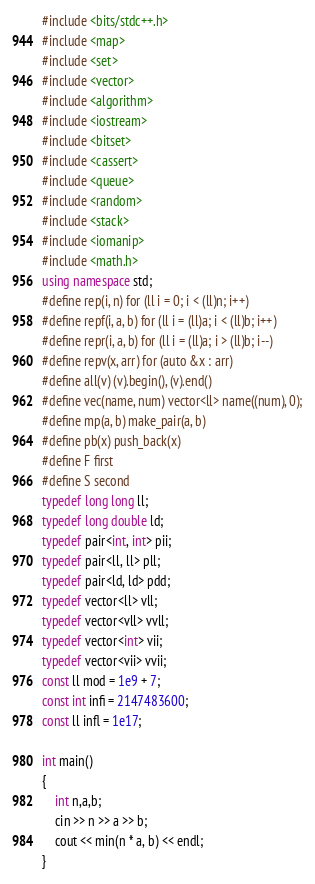Convert code to text. <code><loc_0><loc_0><loc_500><loc_500><_C++_>#include <bits/stdc++.h>
#include <map>
#include <set>
#include <vector>
#include <algorithm>
#include <iostream>
#include <bitset>
#include <cassert>
#include <queue>
#include <random>
#include <stack>
#include <iomanip>
#include <math.h>
using namespace std;
#define rep(i, n) for (ll i = 0; i < (ll)n; i++)
#define repf(i, a, b) for (ll i = (ll)a; i < (ll)b; i++)
#define repr(i, a, b) for (ll i = (ll)a; i > (ll)b; i--)
#define repv(x, arr) for (auto &x : arr)
#define all(v) (v).begin(), (v).end()
#define vec(name, num) vector<ll> name((num), 0);
#define mp(a, b) make_pair(a, b)
#define pb(x) push_back(x)
#define F first
#define S second
typedef long long ll;
typedef long double ld;
typedef pair<int, int> pii;
typedef pair<ll, ll> pll;
typedef pair<ld, ld> pdd;
typedef vector<ll> vll;
typedef vector<vll> vvll;
typedef vector<int> vii;
typedef vector<vii> vvii;
const ll mod = 1e9 + 7;
const int infi = 2147483600;
const ll infl = 1e17;

int main()
{
    int n,a,b;
    cin >> n >> a >> b;
    cout << min(n * a, b) << endl;
}
</code> 